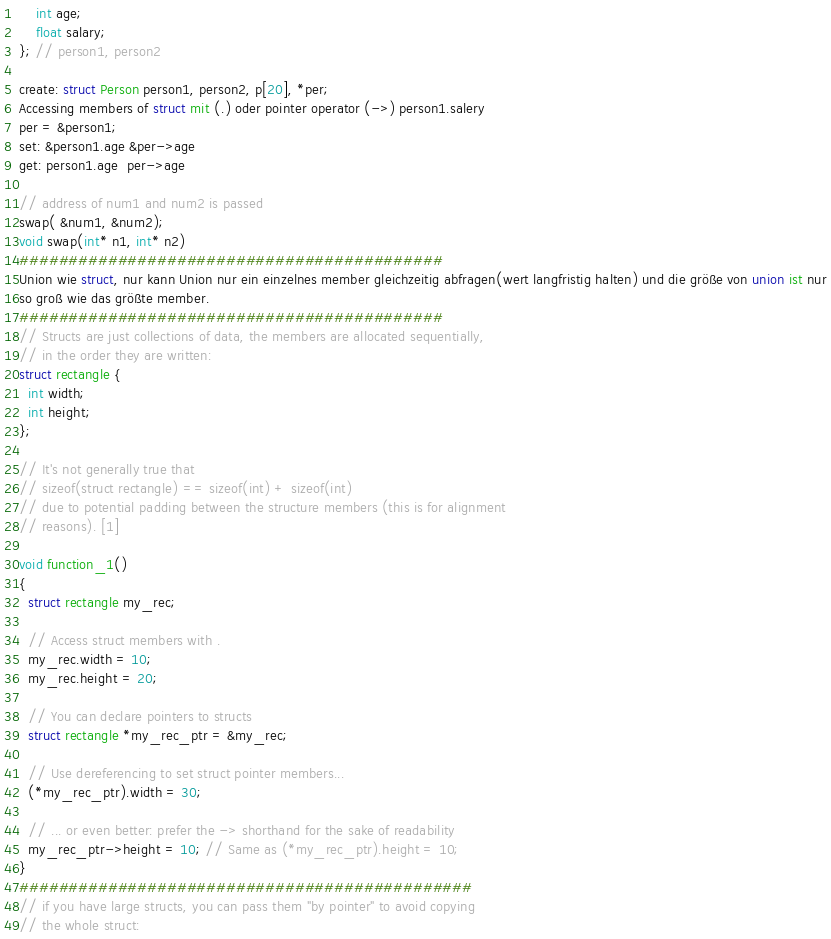Convert code to text. <code><loc_0><loc_0><loc_500><loc_500><_C_>    int age;
    float salary;
}; // person1, person2

create: struct Person person1, person2, p[20], *per;
Accessing members of struct mit (.) oder pointer operator (->) person1.salery
per = &person1;
set: &person1.age &per->age
get: person1.age  per->age

// address of num1 and num2 is passed
swap( &num1, &num2);
void swap(int* n1, int* n2)
###########################################
Union wie struct, nur kann Union nur ein einzelnes member gleichzeitig abfragen(wert langfristig halten) und die größe von union ist nur
so groß wie das größte member.
###########################################
// Structs are just collections of data, the members are allocated sequentially,
// in the order they are written:
struct rectangle {
  int width;
  int height;
};

// It's not generally true that
// sizeof(struct rectangle) == sizeof(int) + sizeof(int)
// due to potential padding between the structure members (this is for alignment
// reasons). [1]

void function_1()
{
  struct rectangle my_rec;

  // Access struct members with .
  my_rec.width = 10;
  my_rec.height = 20;

  // You can declare pointers to structs
  struct rectangle *my_rec_ptr = &my_rec;

  // Use dereferencing to set struct pointer members...
  (*my_rec_ptr).width = 30;

  // ... or even better: prefer the -> shorthand for the sake of readability
  my_rec_ptr->height = 10; // Same as (*my_rec_ptr).height = 10;
}
##############################################
// if you have large structs, you can pass them "by pointer" to avoid copying
// the whole struct:</code> 